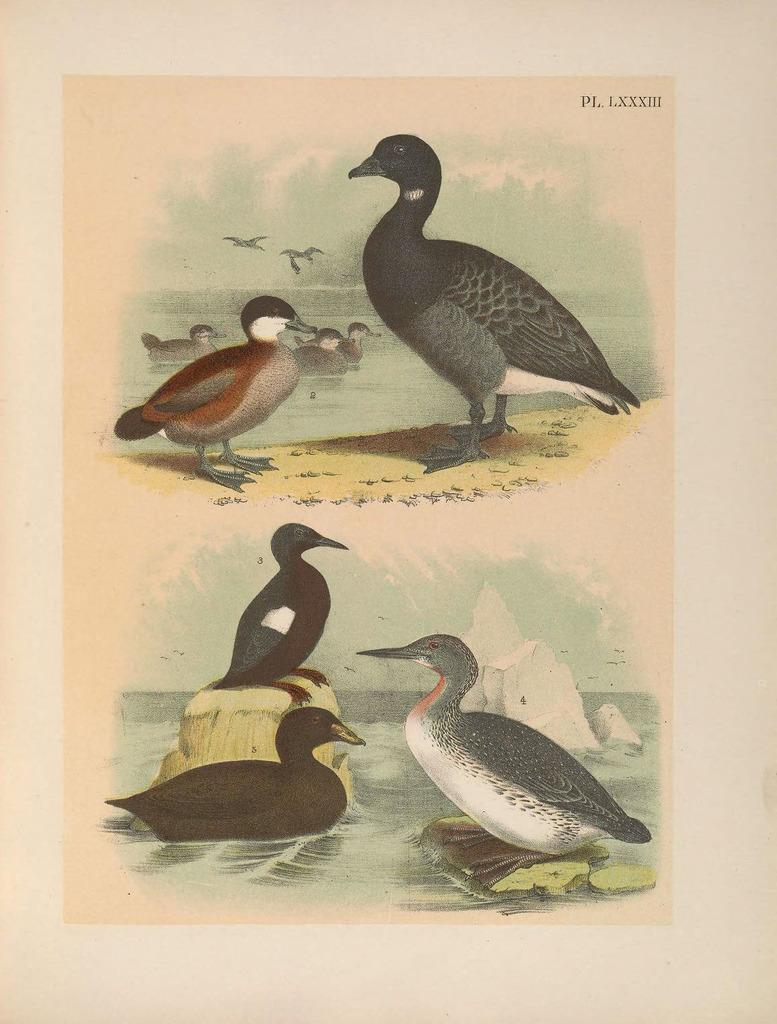In one or two sentences, can you explain what this image depicts? In this picture I can see printed images of ducks on the paper. I can see water, rocks and couple birds flying and I can see text at the top right corner of the picture. 